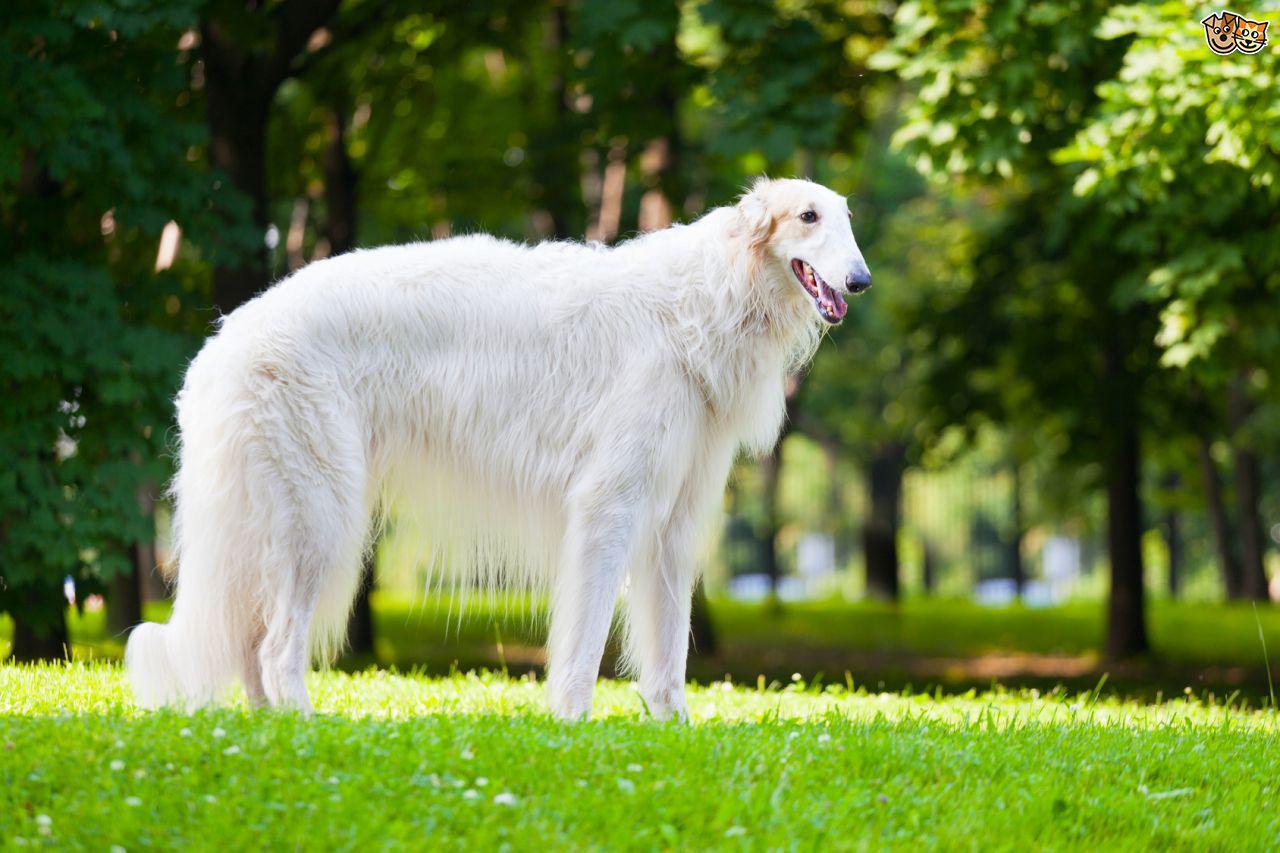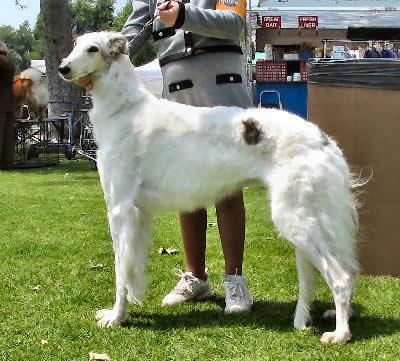The first image is the image on the left, the second image is the image on the right. Given the left and right images, does the statement "There are no more than two dogs." hold true? Answer yes or no. Yes. The first image is the image on the left, the second image is the image on the right. Analyze the images presented: Is the assertion "There are more than two dogs." valid? Answer yes or no. No. 